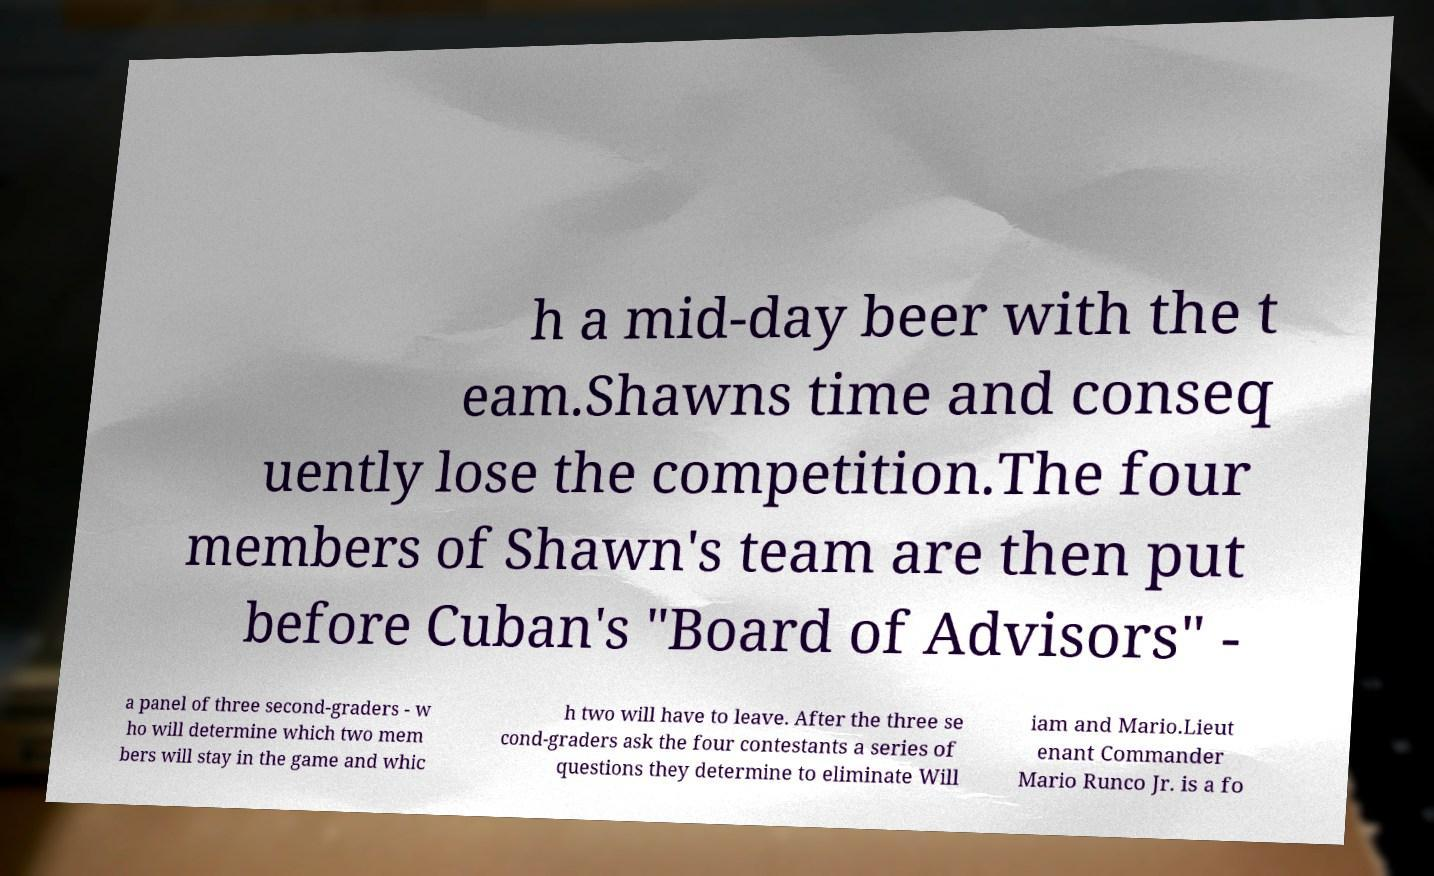Please read and relay the text visible in this image. What does it say? h a mid-day beer with the t eam.Shawns time and conseq uently lose the competition.The four members of Shawn's team are then put before Cuban's "Board of Advisors" - a panel of three second-graders - w ho will determine which two mem bers will stay in the game and whic h two will have to leave. After the three se cond-graders ask the four contestants a series of questions they determine to eliminate Will iam and Mario.Lieut enant Commander Mario Runco Jr. is a fo 